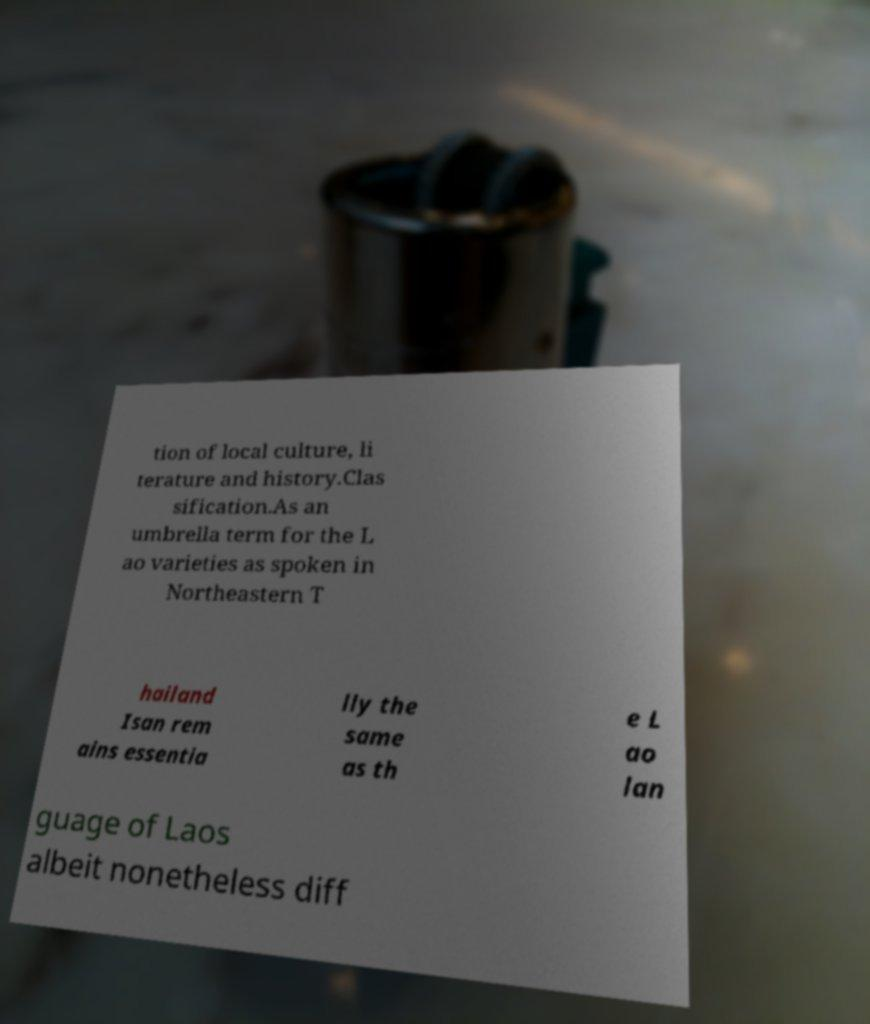Please read and relay the text visible in this image. What does it say? tion of local culture, li terature and history.Clas sification.As an umbrella term for the L ao varieties as spoken in Northeastern T hailand Isan rem ains essentia lly the same as th e L ao lan guage of Laos albeit nonetheless diff 